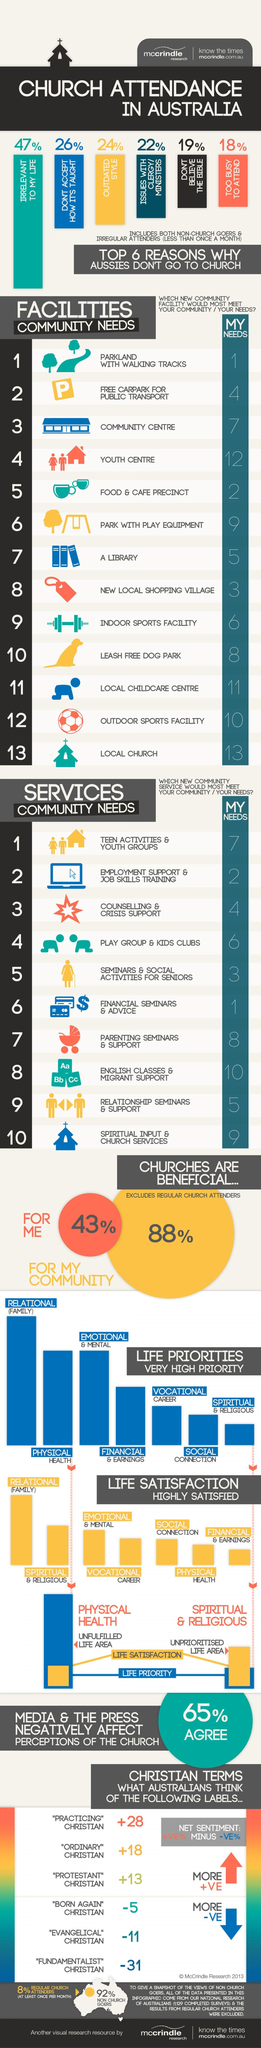how many do not believe in the bible
Answer the question with a short phrase. 19% which services community needs is at the same ranking as my needs employment support & job skills training what is the ranking of a library in my needs 5 what is the reason stated by 24% of the aussies outdated style what is the number one ranking for both my needs and facilities community needs parkland with walking tracks how many think that churches are beneficial for their community 88% 